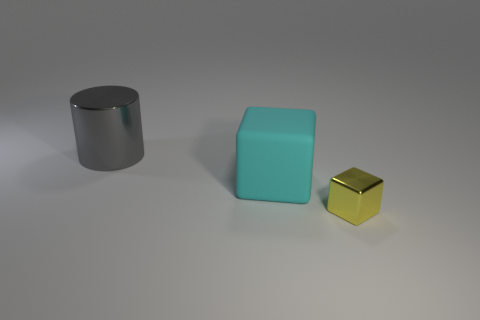Add 2 small yellow blocks. How many objects exist? 5 Subtract all cylinders. How many objects are left? 2 Add 1 large brown objects. How many large brown objects exist? 1 Subtract 0 green balls. How many objects are left? 3 Subtract all big red cubes. Subtract all yellow blocks. How many objects are left? 2 Add 2 big cubes. How many big cubes are left? 3 